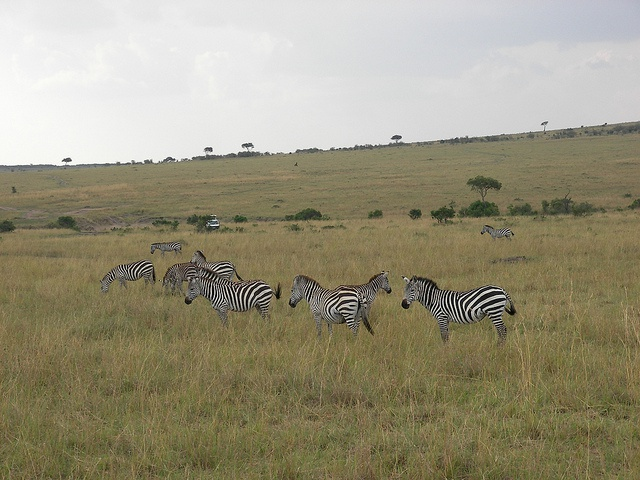Describe the objects in this image and their specific colors. I can see zebra in lightgray, black, gray, and darkgray tones, zebra in lightgray, gray, black, and darkgray tones, zebra in lightgray, black, gray, and darkgray tones, zebra in lightgray, gray, black, and darkgray tones, and zebra in lightgray, gray, black, and darkgray tones in this image. 